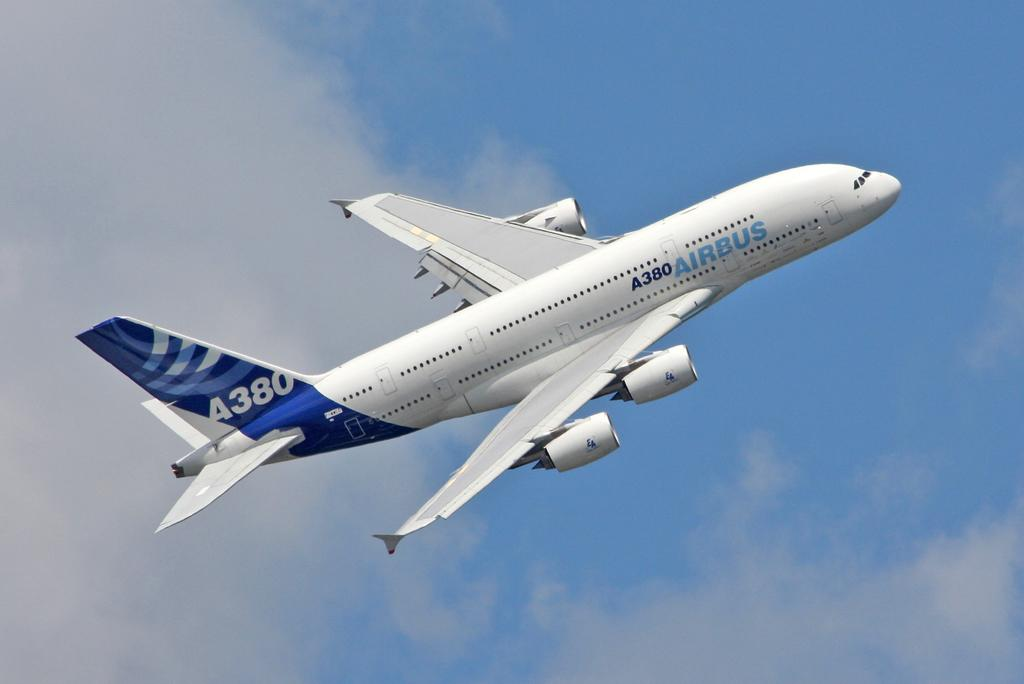Provide a one-sentence caption for the provided image. An Airbus A380 is taking off into the sky. 